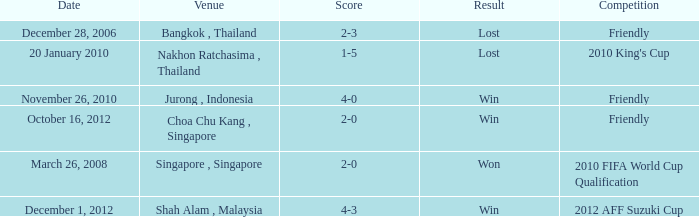Name the venue for friendly competition october 16, 2012 Choa Chu Kang , Singapore. 